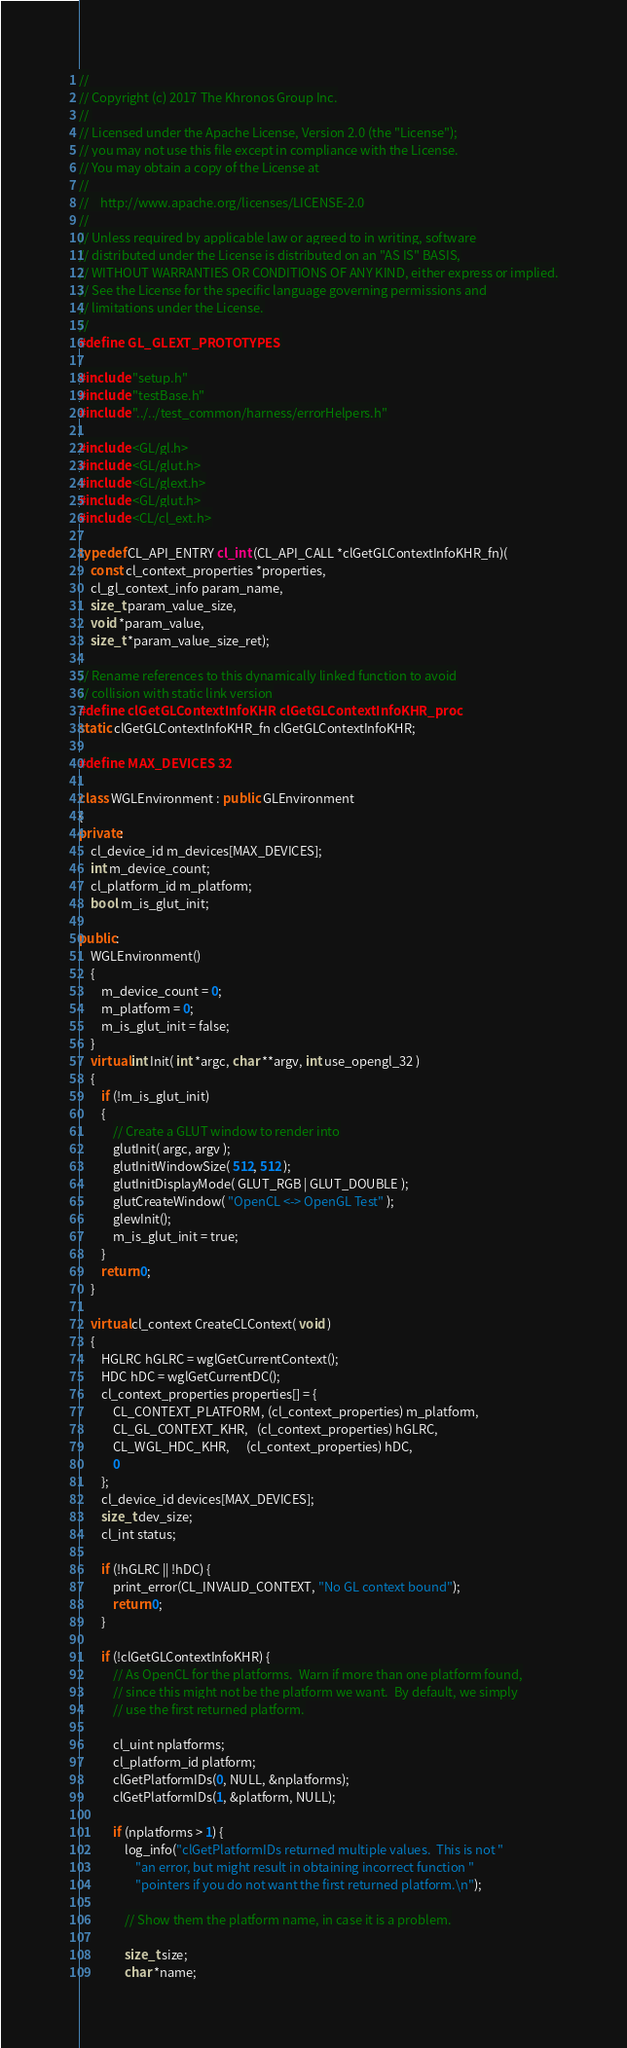Convert code to text. <code><loc_0><loc_0><loc_500><loc_500><_C++_>//
// Copyright (c) 2017 The Khronos Group Inc.
// 
// Licensed under the Apache License, Version 2.0 (the "License");
// you may not use this file except in compliance with the License.
// You may obtain a copy of the License at
//
//    http://www.apache.org/licenses/LICENSE-2.0
//
// Unless required by applicable law or agreed to in writing, software
// distributed under the License is distributed on an "AS IS" BASIS,
// WITHOUT WARRANTIES OR CONDITIONS OF ANY KIND, either express or implied.
// See the License for the specific language governing permissions and
// limitations under the License.
//
#define GL_GLEXT_PROTOTYPES

#include "setup.h"
#include "testBase.h"
#include "../../test_common/harness/errorHelpers.h"

#include <GL/gl.h>
#include <GL/glut.h>
#include <GL/glext.h>
#include <GL/glut.h>
#include <CL/cl_ext.h>

typedef CL_API_ENTRY cl_int (CL_API_CALL *clGetGLContextInfoKHR_fn)(
    const cl_context_properties *properties,
    cl_gl_context_info param_name,
    size_t param_value_size,
    void *param_value,
    size_t *param_value_size_ret);

// Rename references to this dynamically linked function to avoid
// collision with static link version
#define clGetGLContextInfoKHR clGetGLContextInfoKHR_proc
static clGetGLContextInfoKHR_fn clGetGLContextInfoKHR;

#define MAX_DEVICES 32

class WGLEnvironment : public GLEnvironment
{
private:
    cl_device_id m_devices[MAX_DEVICES];
    int m_device_count;
    cl_platform_id m_platform;
    bool m_is_glut_init;

public:
    WGLEnvironment()
    {
        m_device_count = 0;
        m_platform = 0;
        m_is_glut_init = false;
    }
    virtual int Init( int *argc, char **argv, int use_opengl_32 )
    {
        if (!m_is_glut_init)
        {
            // Create a GLUT window to render into
            glutInit( argc, argv );
            glutInitWindowSize( 512, 512 );
            glutInitDisplayMode( GLUT_RGB | GLUT_DOUBLE );
            glutCreateWindow( "OpenCL <-> OpenGL Test" );
            glewInit();
            m_is_glut_init = true;
        }
        return 0;
    }

    virtual cl_context CreateCLContext( void )
    {
        HGLRC hGLRC = wglGetCurrentContext();
        HDC hDC = wglGetCurrentDC();
        cl_context_properties properties[] = {
            CL_CONTEXT_PLATFORM, (cl_context_properties) m_platform,
            CL_GL_CONTEXT_KHR,   (cl_context_properties) hGLRC,
            CL_WGL_HDC_KHR,      (cl_context_properties) hDC,
            0
        };
        cl_device_id devices[MAX_DEVICES];
        size_t dev_size;
        cl_int status;

        if (!hGLRC || !hDC) {
            print_error(CL_INVALID_CONTEXT, "No GL context bound");
            return 0;
        }

        if (!clGetGLContextInfoKHR) {
            // As OpenCL for the platforms.  Warn if more than one platform found,
            // since this might not be the platform we want.  By default, we simply
            // use the first returned platform.

            cl_uint nplatforms;
            cl_platform_id platform;
            clGetPlatformIDs(0, NULL, &nplatforms);
            clGetPlatformIDs(1, &platform, NULL);

            if (nplatforms > 1) {
                log_info("clGetPlatformIDs returned multiple values.  This is not "
                    "an error, but might result in obtaining incorrect function "
                    "pointers if you do not want the first returned platform.\n");

                // Show them the platform name, in case it is a problem.

                size_t size;
                char *name;
</code> 